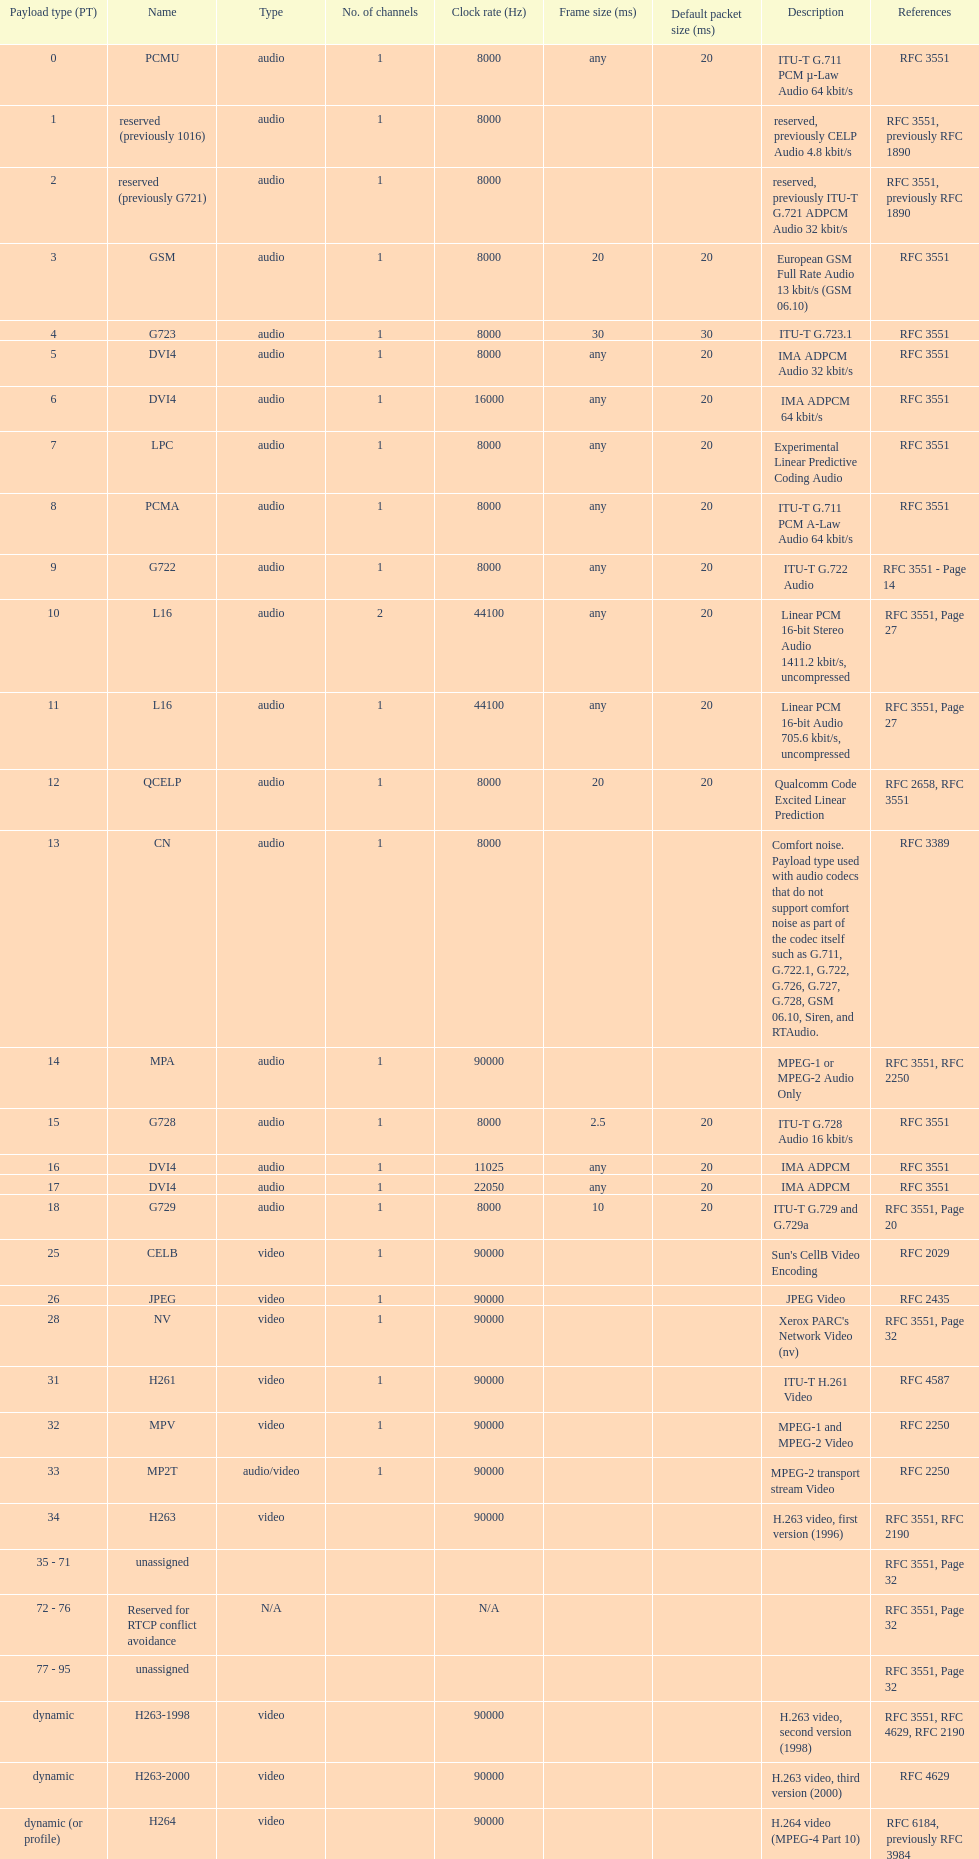Other than audio, what type of payload types are there? Video. 